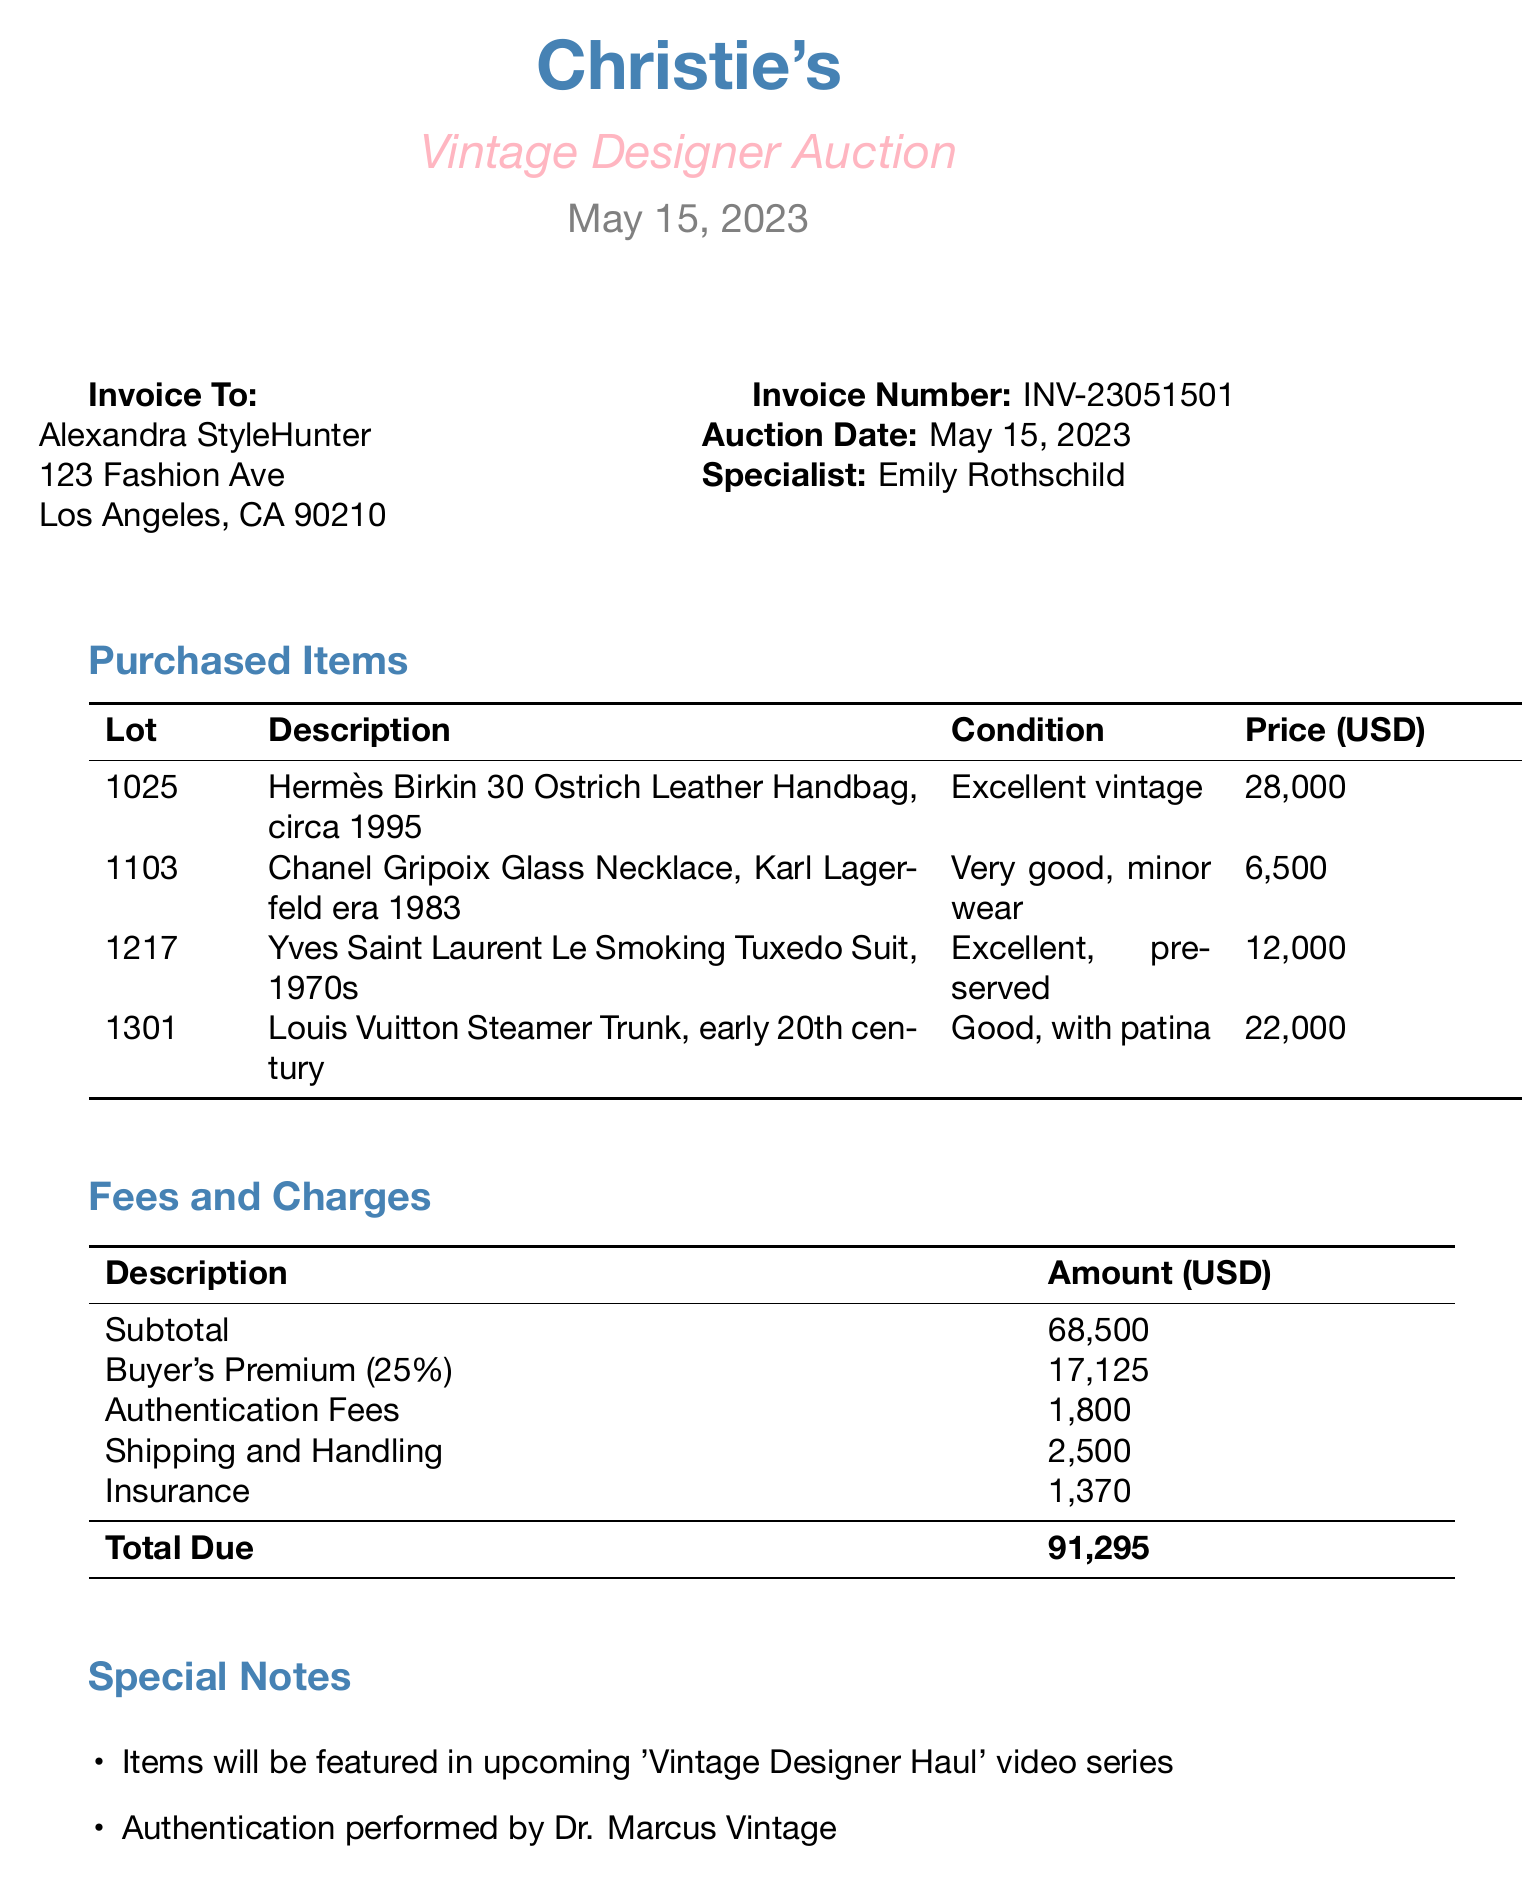What is the auction house's name? The auction house mentioned in the document is Christie's.
Answer: Christie's What is the auction date? The auction date is explicitly provided in the document as May 15, 2023.
Answer: May 15, 2023 What is the buyer's premium rate? The document specifies the buyer's premium rate as 25%.
Answer: 25% What is the total due amount? The total due is calculated by summing various fees, which is stated as 91,295.
Answer: 91,295 Who is the authentication expert? The document identifies Dr. Marcus Vintage as the authentication expert.
Answer: Dr. Marcus Vintage What is the condition of the Chanel Gripoix Glass Necklace? The document notes the condition of the necklace as very good, with minor wear.
Answer: Very good, minor wear What was the hammer price for the Hermès Birkin handbag? The hammer price listed for the Hermès Birkin handbag is 28,000.
Answer: 28,000 What are the special notes regarding the items? The special notes indicate the items will be featured in a video series and include payment terms.
Answer: Items will be featured in upcoming 'Vintage Designer Haul' video series How many items were purchased? The document lists four items in the purchased items section.
Answer: Four 